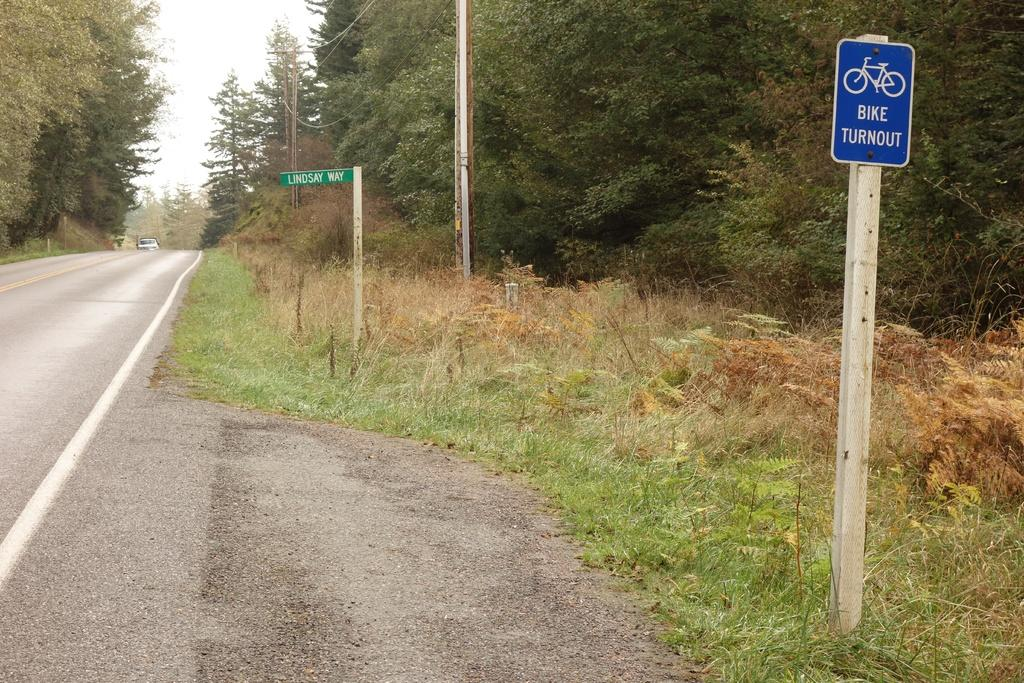<image>
Describe the image concisely. A bike turnout sign is beside a road 